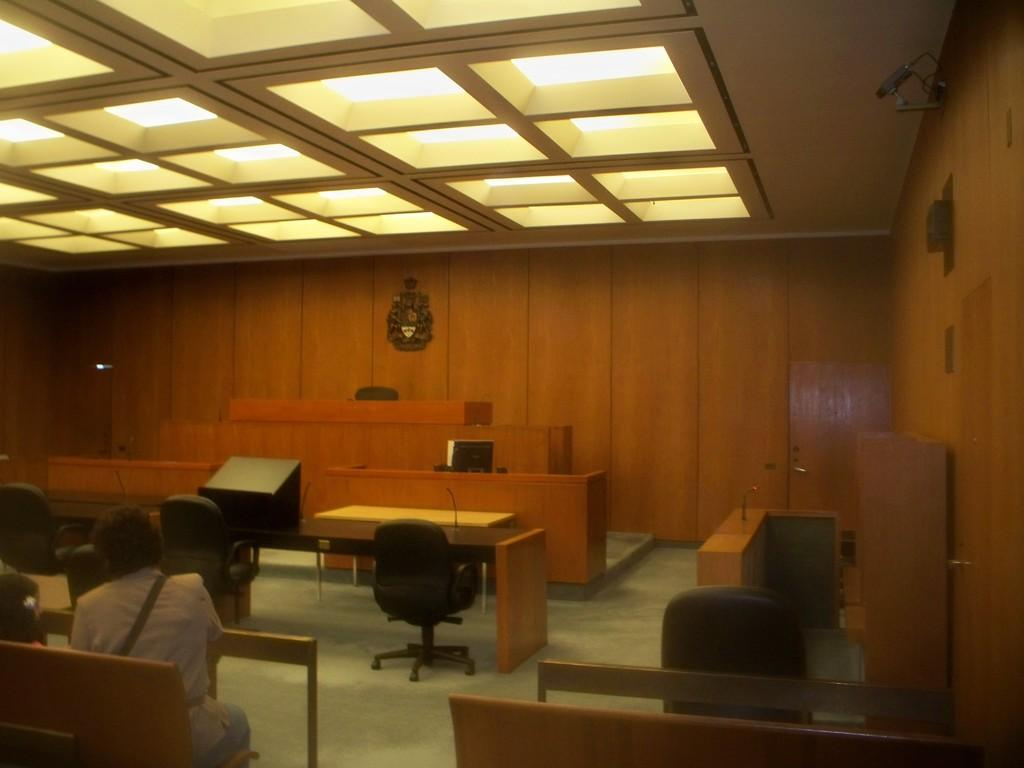What type of furniture is present in the room? There are tables and chairs in the room. Can you describe the position of the person in the image? A person is sitting on a chair on the left side of the image. What material is used for the wall in the room? The wall in the room is made of wood. What part of the room is visible at the top of the image? The ceiling is visible in the image. What type of oatmeal is being served on the table in the image? There is no oatmeal present in the image; the image only shows tables, chairs, a person sitting on a chair, a wooden wall, and a visible ceiling. Is the person wearing a slip in the image? There is no information about the person's clothing in the image, so it cannot be determined if they are wearing a slip or not. 